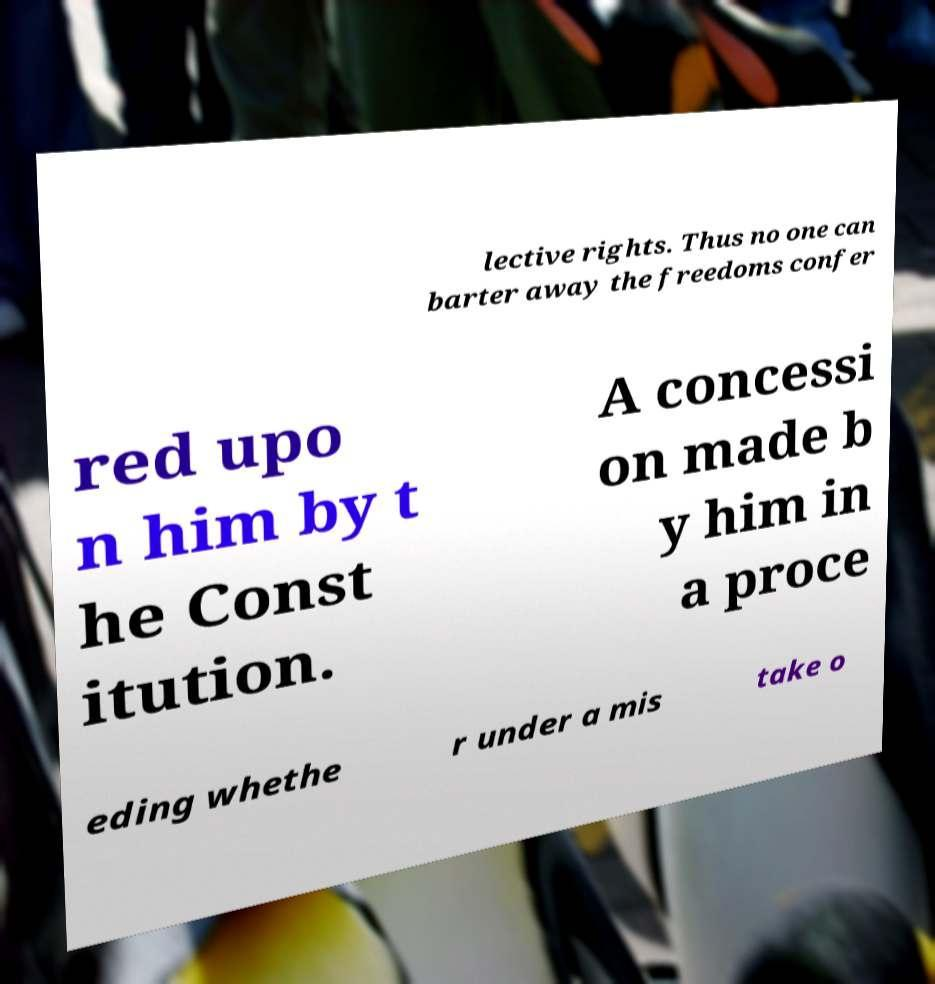Can you accurately transcribe the text from the provided image for me? lective rights. Thus no one can barter away the freedoms confer red upo n him by t he Const itution. A concessi on made b y him in a proce eding whethe r under a mis take o 